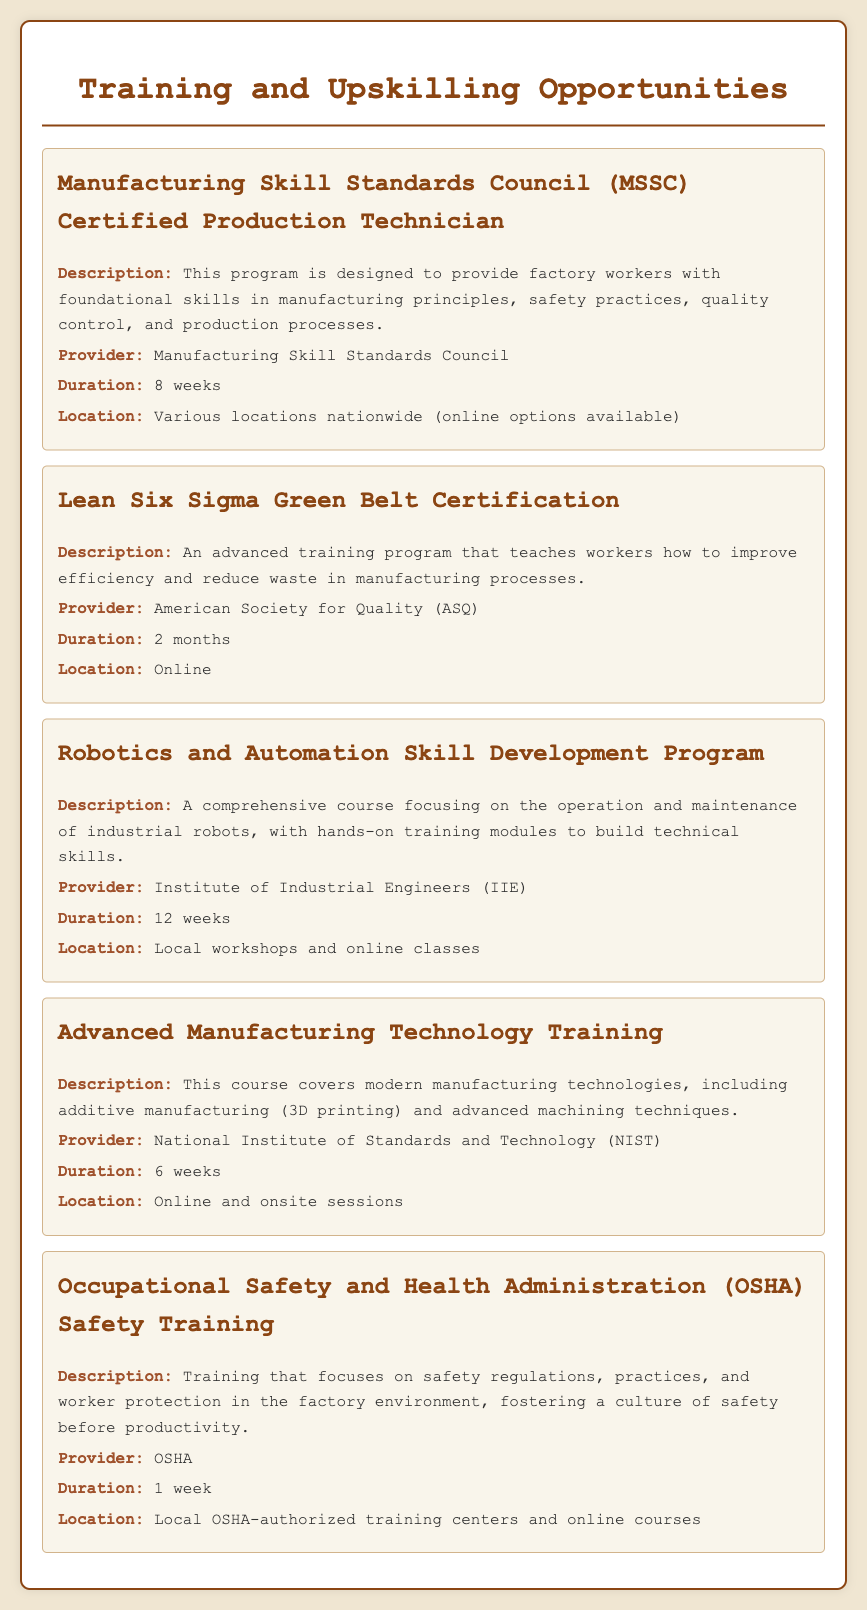what is the duration of the MSSC Certified Production Technician program? The duration of the program is explicitly stated in the document, which mentions it lasts for 8 weeks.
Answer: 8 weeks who is the provider of the Lean Six Sigma Green Belt Certification? The document lists American Society for Quality (ASQ) as the provider of this certification.
Answer: American Society for Quality (ASQ) what type of training does the OSHA Safety Training focus on? The document specifies that this training focuses on safety regulations, practices, and worker protection in the factory environment.
Answer: Safety regulations how long is the Robotics and Automation Skill Development Program? The program duration is noted in the document as lasting for 12 weeks.
Answer: 12 weeks what is the primary focus of the Advanced Manufacturing Technology Training course? The course covers modern manufacturing technologies, including additive manufacturing and advanced machining techniques.
Answer: Modern manufacturing technologies where is the Robotics and Automation Skill Development Program offered? According to the document, it is available at local workshops and online classes.
Answer: Local workshops and online classes what is a unique qualification of the MSSC Certified Production Technician program? The program is designed to provide foundational skills in various manufacturing principles, signifying its introductory nature.
Answer: Foundational skills how many total weeks are required for the Occupational Safety and Health Administration Safety Training? The document indicates that this training takes only 1 week to complete.
Answer: 1 week 